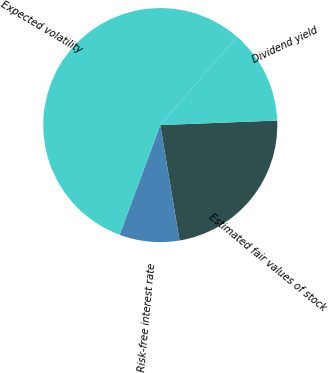Convert chart. <chart><loc_0><loc_0><loc_500><loc_500><pie_chart><fcel>Estimated fair values of stock<fcel>Risk-free interest rate<fcel>Expected volatility<fcel>Dividend yield<nl><fcel>22.99%<fcel>8.28%<fcel>55.71%<fcel>13.02%<nl></chart> 